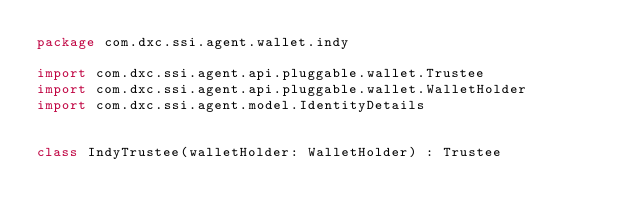<code> <loc_0><loc_0><loc_500><loc_500><_Kotlin_>package com.dxc.ssi.agent.wallet.indy

import com.dxc.ssi.agent.api.pluggable.wallet.Trustee
import com.dxc.ssi.agent.api.pluggable.wallet.WalletHolder
import com.dxc.ssi.agent.model.IdentityDetails


class IndyTrustee(walletHolder: WalletHolder) : Trustee</code> 